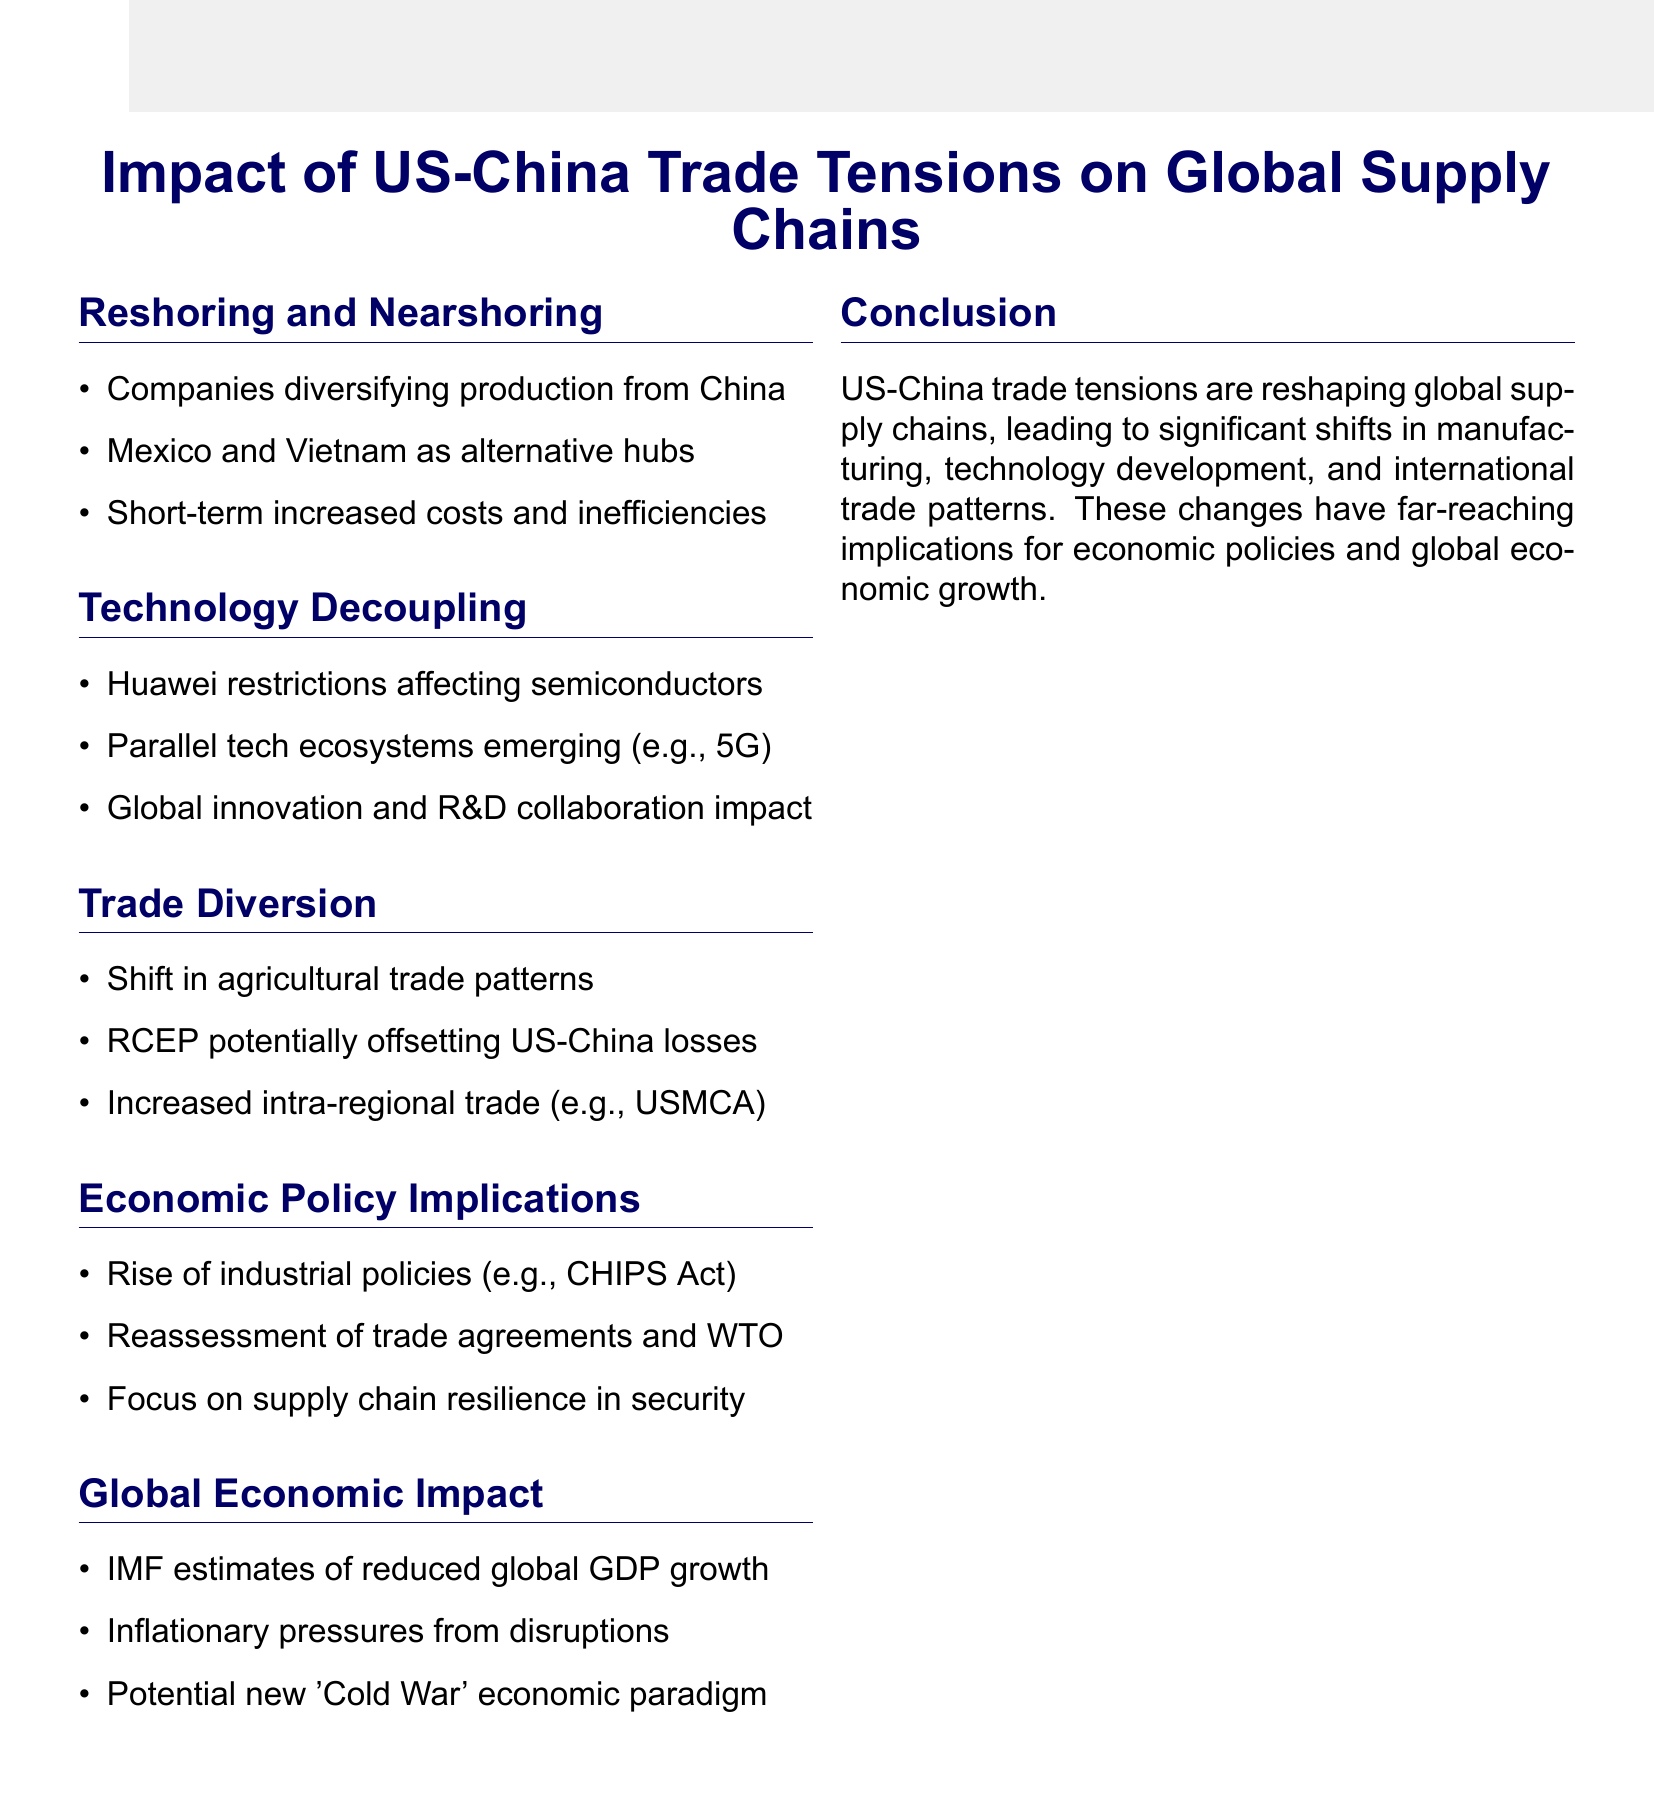What companies are diversifying production away from China? Companies like Apple and Samsung are mentioned as diversifying production, indicating their strategic shift.
Answer: Apple and Samsung Which countries are benefiting as alternative manufacturing hubs? The document lists Mexico and Vietnam as key regions gaining from the reshoring and nearshoring trends.
Answer: Mexico and Vietnam What are the potential short-term effects of reshoring? Increased costs and potential inefficiencies are noted as ramifications of the shift in manufacturing patterns.
Answer: Increased costs and potential inefficiencies What is one implication of technology decoupling mentioned? The restrictions on Huawei are stated as having an impact on the semiconductor industry, suggestive of broader tech issues.
Answer: Restrictions on Huawei What does the RCEP agreement aim to do? The document states that the RCEP agreement could potentially offset some of the trade losses between the US and China, highlighting its role in trade diversification.
Answer: Offset some US-China trade losses What act in the US represents a rise in industrial policies? The CHIPS Act is specifically mentioned as an example of new industrial policies that have emerged in response to trade tensions.
Answer: CHIPS Act What are the IMF's estimates related to global GDP growth? The document references IMF estimates projecting reduced global GDP growth as a consequence of trade tensions.
Answer: Reduced global GDP growth What economic paradigm might emerge according to the document? The possibility of a new 'Cold War' economic paradigm is discussed, reflecting the arising geopolitical tensions.
Answer: New 'Cold War' economic paradigm 